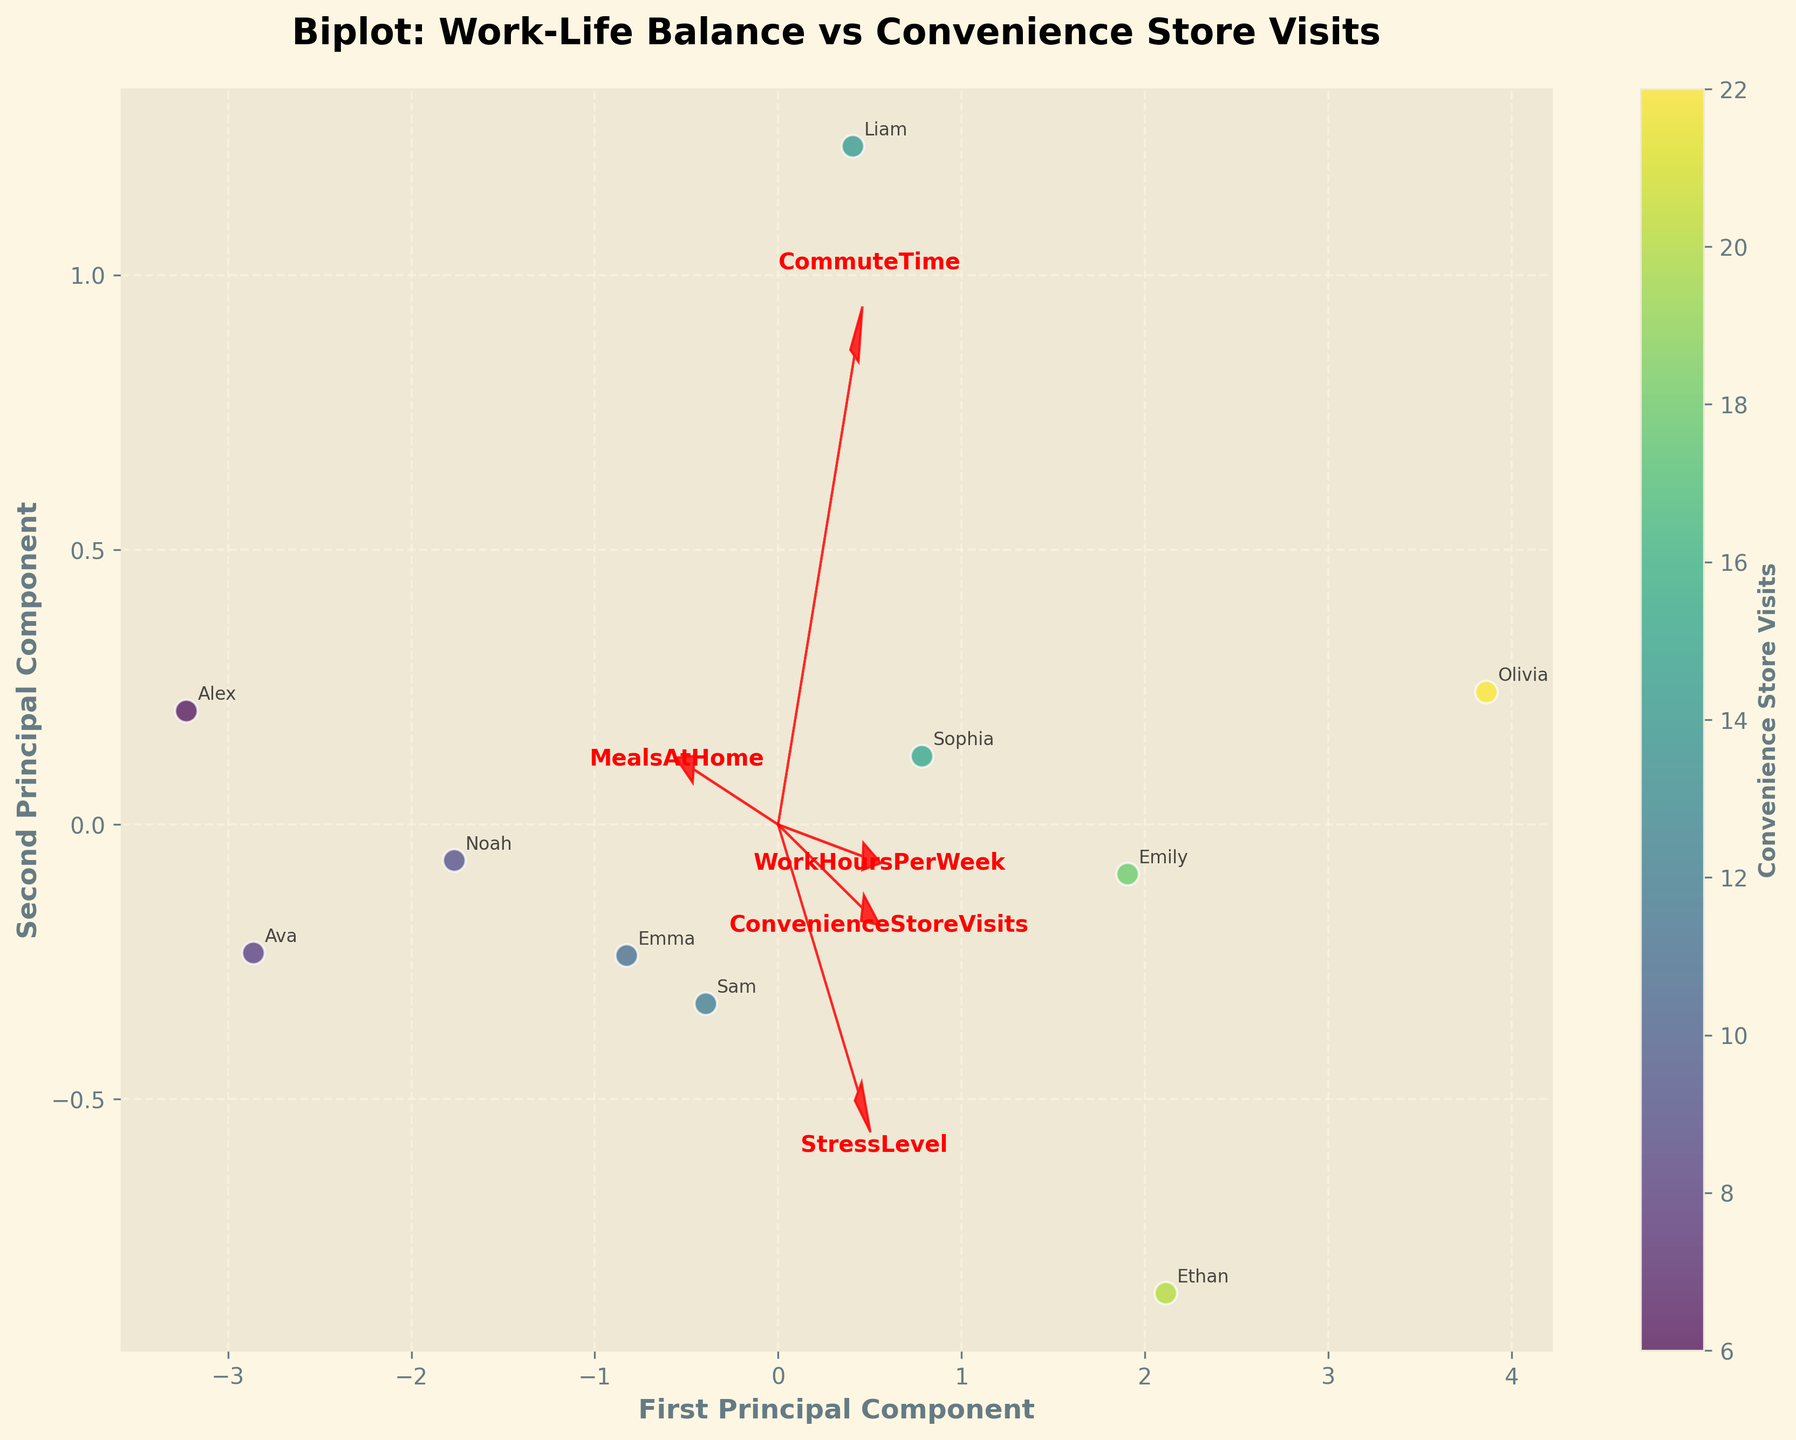What is the title of the figure? The figure title is typically located at the top of the plot and helps summarize the content. In this case, it reads 'Biplot: Work-Life Balance vs Convenience Store Visits'.
Answer: Biplot: Work-Life Balance vs Convenience Store Visits How many principal components are displayed on the biplot? The biplot usually shows the principal components on the x and y-axes. Here, there are two principal components.
Answer: Two Which variable has the smallest arrow length in the biplot? The arrow length in a biplot represents the contribution of each variable to the principal components. A smaller arrow means a smaller contribution. By examining the arrows, 'MealsAtHome' appears to have the smallest arrow length.
Answer: MealsAtHome Which two variables seem to be most positively correlated? Variables in a biplot are positively correlated if their arrows point in similar directions. By assessing the directions, 'WorkHoursPerWeek' and 'StressLevel' arrows point in similar directions.
Answer: WorkHoursPerWeek and StressLevel Who has the highest number of convenience store visits? Each data point represents an individual, with annotations for easy identification. The color intensity can also indicate the frequency of visits. Olivia appears to have the highest value.
Answer: Olivia What is the color indicating in the plot? In the biplot, the color gradient corresponds to the frequency of convenience store visits, with a color bar indicating this relationship.
Answer: Convenience Store Visits Which variable is most negatively correlated with 'MealsAtHome'? Variables are negatively correlated if their arrows point in opposite directions. 'ConvenienceStoreVisits' arrow points in almost the exact opposite direction to 'MealsAtHome'.
Answer: ConvenienceStoreVisits Compare the principal component scores of Sam and Alex. Who is closer to the origin? The proximity to the origin in a biplot can be assessed by the distance of the data points from the (0,0) point. By inspecting the distances, Alex is closer to the origin.
Answer: Alex Does 'CommuteTime' have a more significant influence on the first or second principal component? The influence of a variable on a principal component can be evaluated by the arrow's direction and projection. 'CommuteTime' arrow points more horizontally, indicating a stronger influence on the first principal component.
Answer: First principal component What is the relationship between 'WorkHoursPerWeek' and 'ConvenienceStoreVisits'? The relative directions and lengths of arrows in the biplot illustrate the relationships. 'WorkHoursPerWeek' and 'ConvenienceStoreVisits' arrows point in a similar direction, indicating a positive relationship.
Answer: Positive relationship 